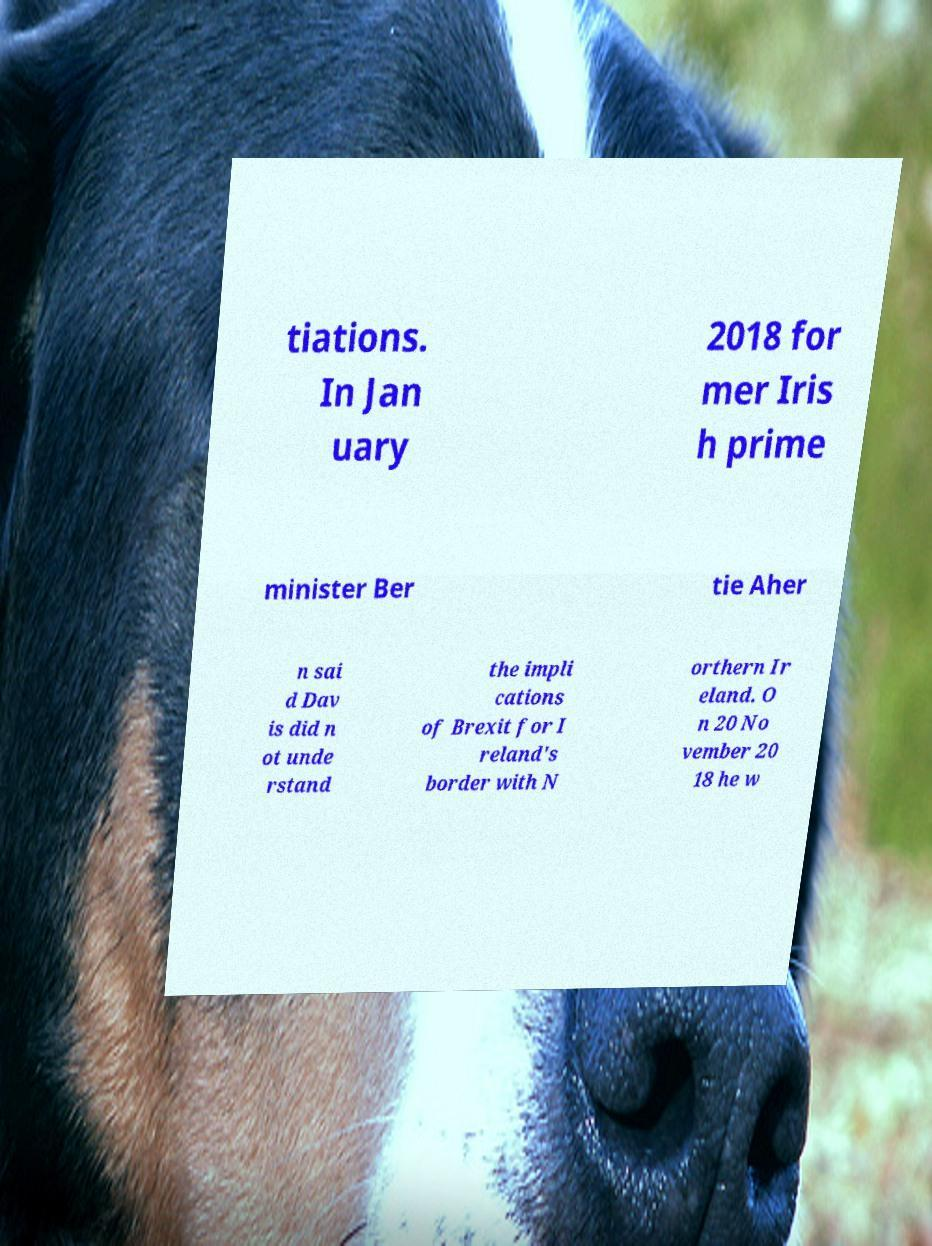Can you read and provide the text displayed in the image?This photo seems to have some interesting text. Can you extract and type it out for me? tiations. In Jan uary 2018 for mer Iris h prime minister Ber tie Aher n sai d Dav is did n ot unde rstand the impli cations of Brexit for I reland's border with N orthern Ir eland. O n 20 No vember 20 18 he w 